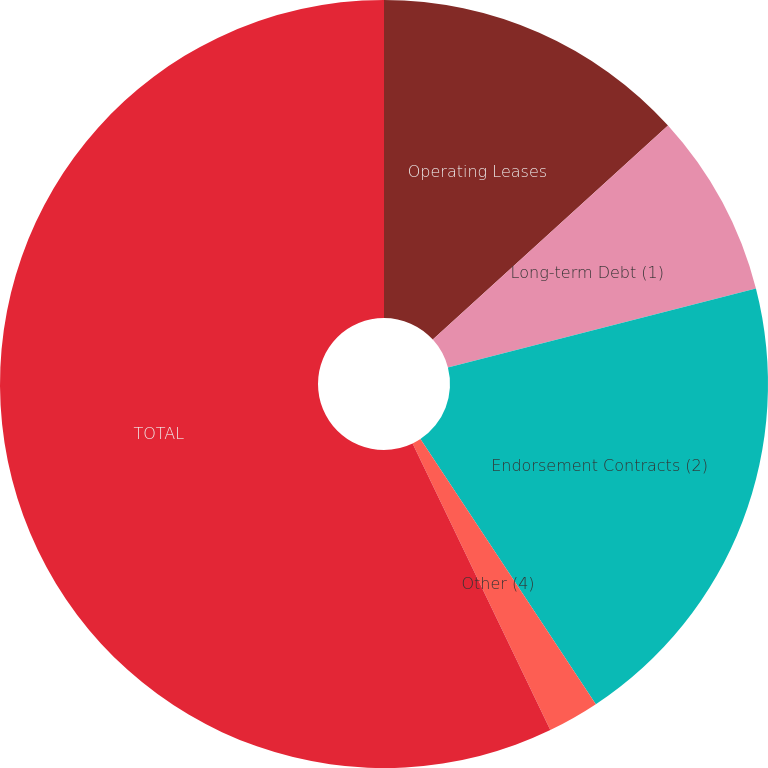Convert chart. <chart><loc_0><loc_0><loc_500><loc_500><pie_chart><fcel>Operating Leases<fcel>Long-term Debt (1)<fcel>Endorsement Contracts (2)<fcel>Other (4)<fcel>TOTAL<nl><fcel>13.25%<fcel>7.75%<fcel>19.7%<fcel>2.17%<fcel>57.13%<nl></chart> 